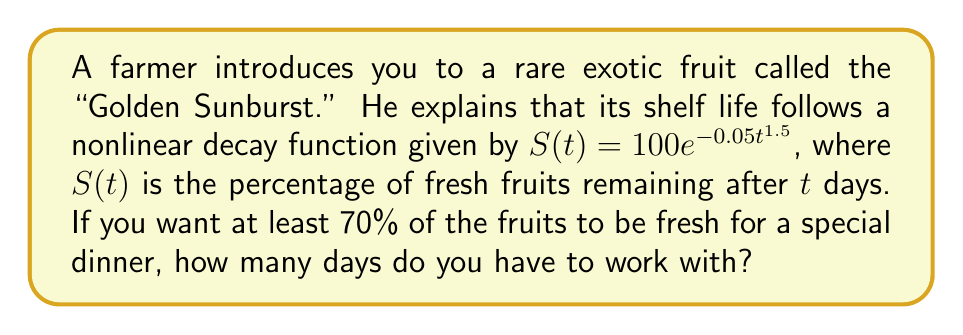Can you answer this question? Let's approach this step-by-step:

1) We're given the decay function: $S(t) = 100e^{-0.05t^{1.5}}$

2) We want to find $t$ when $S(t) = 70$, as this represents 70% of the fruits being fresh.

3) Let's set up the equation:
   $70 = 100e^{-0.05t^{1.5}}$

4) Divide both sides by 100:
   $0.7 = e^{-0.05t^{1.5}}$

5) Take the natural log of both sides:
   $\ln(0.7) = -0.05t^{1.5}$

6) Divide both sides by -0.05:
   $\frac{\ln(0.7)}{-0.05} = t^{1.5}$

7) Take the $\frac{2}{3}$ power of both sides (as this is the inverse of $1.5$ power):
   $(\frac{\ln(0.7)}{-0.05})^{\frac{2}{3}} = t$

8) Calculate:
   $t \approx 6.76$ days

9) Since we need to ensure at least 70% freshness, we round down to the nearest whole number.

Therefore, you have 6 days to work with to ensure at least 70% of the fruits are fresh.
Answer: 6 days 